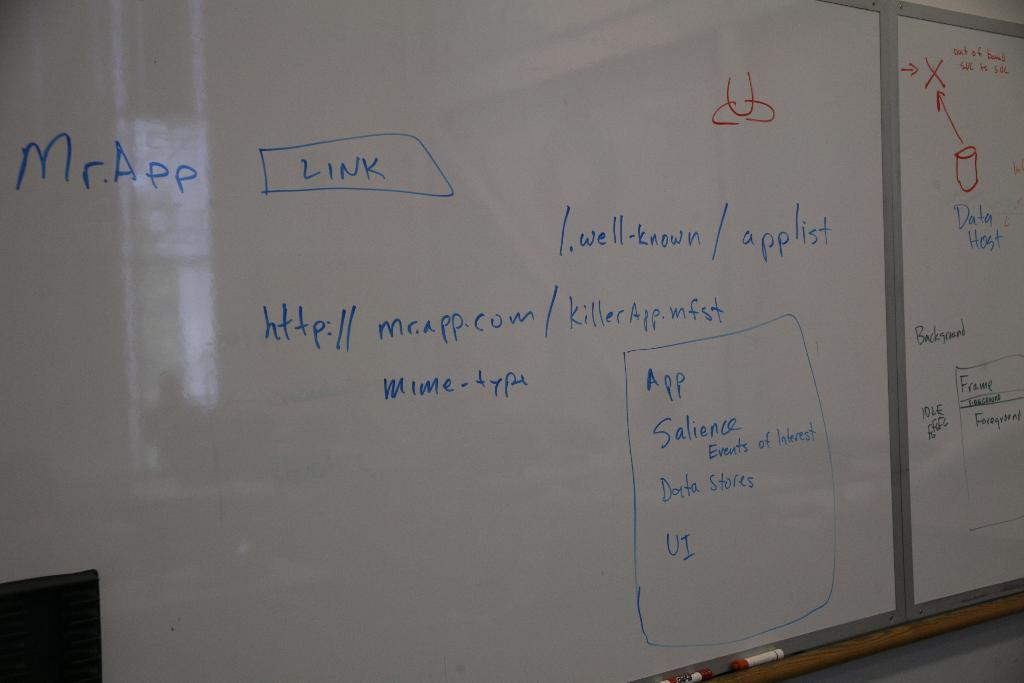Provide a one-sentence caption for the provided image. a white board has the writing with Mr App link on it. 